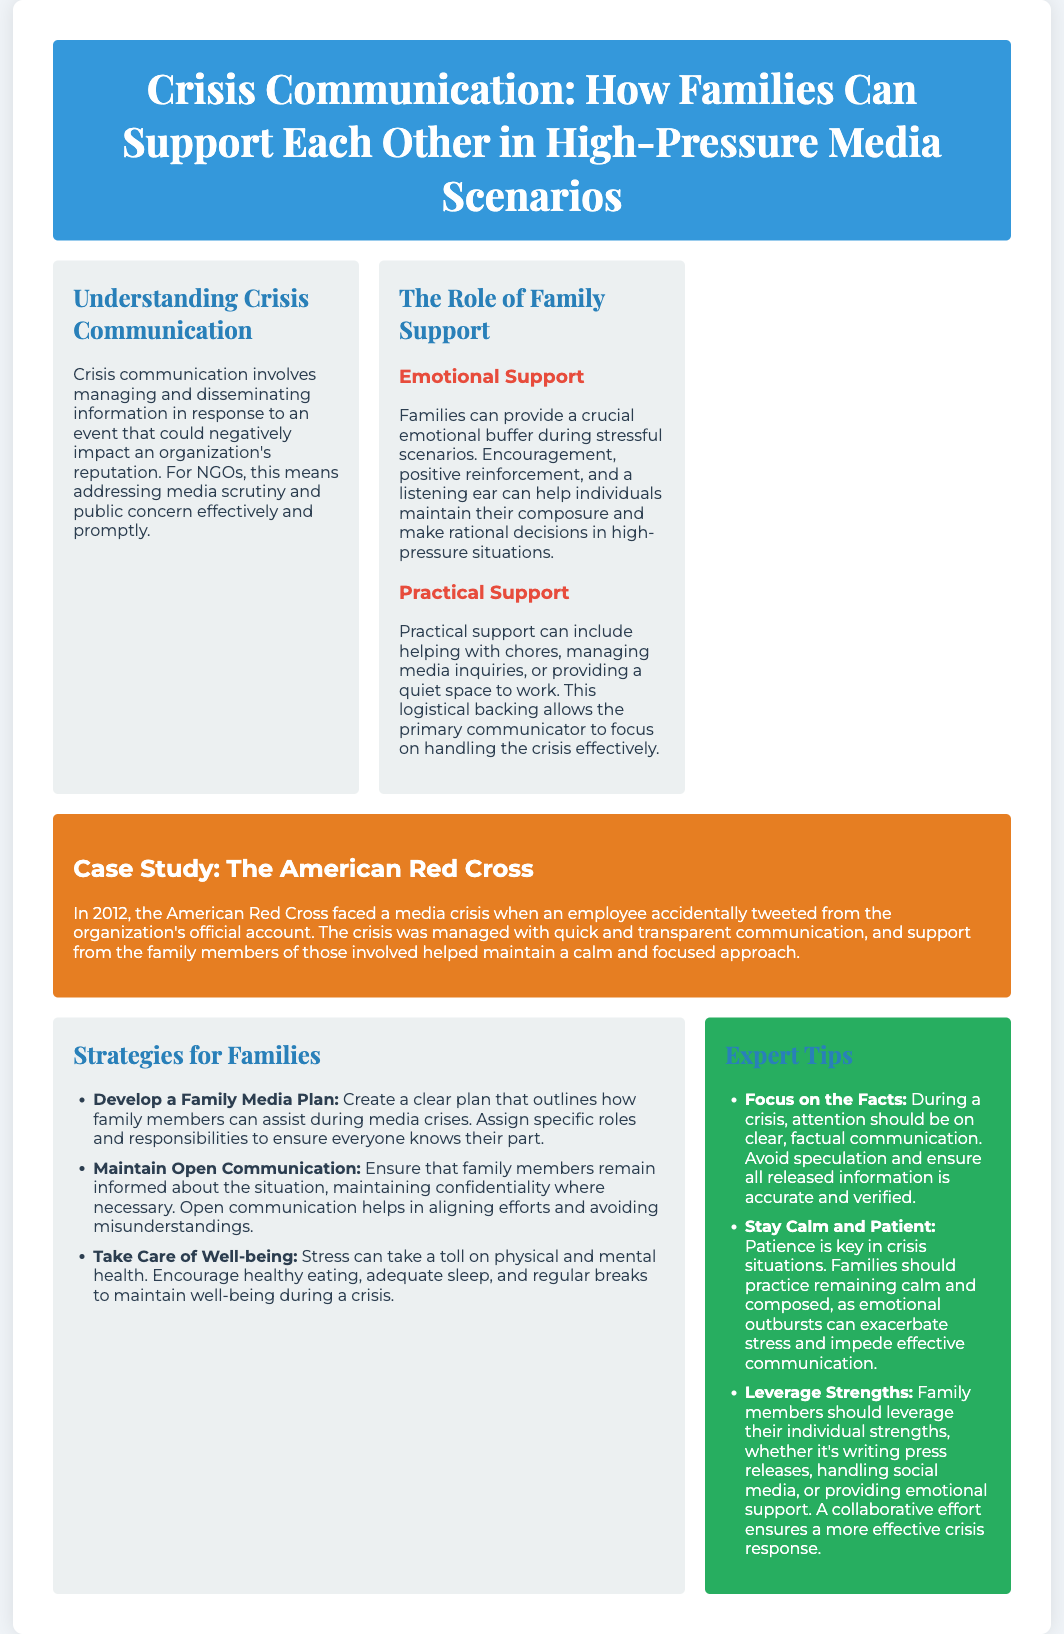What is the title of the poster? The title of the poster is found at the top section, introducing the main topic of the document.
Answer: Crisis Communication: How Families Can Support Each Other in High-Pressure Media Scenarios What year did the American Red Cross crisis occur? The document mentions the year when the American Red Cross faced its media crisis in a case study section.
Answer: 2012 What role do families provide during a crisis according to the poster? The document outlines specific roles families can contribute, specifically focusing on emotional aspects in stressful moments.
Answer: Emotional Support What is the first strategy listed for families? The strategies for families are introduced with specific actions to take during a crisis, and the first strategy is identified in the document.
Answer: Develop a Family Media Plan What type of communication should families focus on during a crisis? The document emphasizes the kind of communication that is crucial for effective management during crisis scenarios.
Answer: Facts How many strategies are listed in the strategies section? The number of strategies outlined in the document's strategies section offers a clear guide for families during a crisis.
Answer: Three What is suggested to maintain well-being during a crisis? The document highlights the importance of certain actions to preserve health and morale during stressful times.
Answer: Healthy eating What color is the header section of the poster? The design choices for the poster, including color usage for various sections, are highlighted in the visual aspect of the document.
Answer: Blue What is the main focus of the expert tips? The expert tips section provides concise pieces of advice relevant to communication and crisis management as outlined in the poster.
Answer: Effective crisis response 